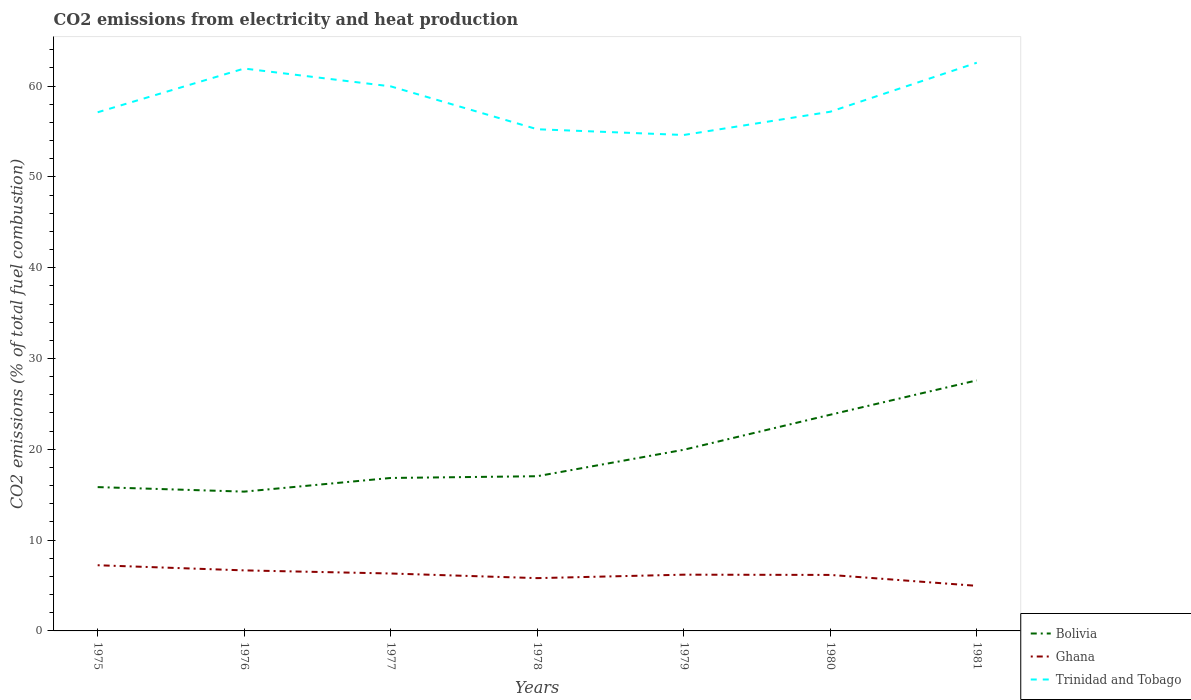How many different coloured lines are there?
Ensure brevity in your answer.  3. Does the line corresponding to Trinidad and Tobago intersect with the line corresponding to Ghana?
Your answer should be compact. No. Is the number of lines equal to the number of legend labels?
Provide a short and direct response. Yes. Across all years, what is the maximum amount of CO2 emitted in Trinidad and Tobago?
Offer a very short reply. 54.62. In which year was the amount of CO2 emitted in Trinidad and Tobago maximum?
Give a very brief answer. 1979. What is the total amount of CO2 emitted in Trinidad and Tobago in the graph?
Your response must be concise. 4.72. What is the difference between the highest and the second highest amount of CO2 emitted in Trinidad and Tobago?
Make the answer very short. 7.96. Is the amount of CO2 emitted in Ghana strictly greater than the amount of CO2 emitted in Trinidad and Tobago over the years?
Ensure brevity in your answer.  Yes. How many years are there in the graph?
Provide a short and direct response. 7. What is the difference between two consecutive major ticks on the Y-axis?
Ensure brevity in your answer.  10. Are the values on the major ticks of Y-axis written in scientific E-notation?
Offer a very short reply. No. Does the graph contain any zero values?
Provide a short and direct response. No. What is the title of the graph?
Offer a terse response. CO2 emissions from electricity and heat production. Does "Mongolia" appear as one of the legend labels in the graph?
Provide a succinct answer. No. What is the label or title of the Y-axis?
Provide a succinct answer. CO2 emissions (% of total fuel combustion). What is the CO2 emissions (% of total fuel combustion) of Bolivia in 1975?
Offer a very short reply. 15.84. What is the CO2 emissions (% of total fuel combustion) in Ghana in 1975?
Offer a very short reply. 7.23. What is the CO2 emissions (% of total fuel combustion) in Trinidad and Tobago in 1975?
Your answer should be compact. 57.12. What is the CO2 emissions (% of total fuel combustion) in Bolivia in 1976?
Your answer should be compact. 15.34. What is the CO2 emissions (% of total fuel combustion) of Ghana in 1976?
Offer a terse response. 6.67. What is the CO2 emissions (% of total fuel combustion) in Trinidad and Tobago in 1976?
Your answer should be compact. 61.93. What is the CO2 emissions (% of total fuel combustion) in Bolivia in 1977?
Your response must be concise. 16.84. What is the CO2 emissions (% of total fuel combustion) in Ghana in 1977?
Give a very brief answer. 6.32. What is the CO2 emissions (% of total fuel combustion) in Trinidad and Tobago in 1977?
Provide a succinct answer. 59.97. What is the CO2 emissions (% of total fuel combustion) of Bolivia in 1978?
Provide a short and direct response. 17.04. What is the CO2 emissions (% of total fuel combustion) of Ghana in 1978?
Offer a terse response. 5.81. What is the CO2 emissions (% of total fuel combustion) of Trinidad and Tobago in 1978?
Provide a short and direct response. 55.25. What is the CO2 emissions (% of total fuel combustion) of Bolivia in 1979?
Offer a very short reply. 19.95. What is the CO2 emissions (% of total fuel combustion) in Ghana in 1979?
Your answer should be very brief. 6.19. What is the CO2 emissions (% of total fuel combustion) in Trinidad and Tobago in 1979?
Offer a very short reply. 54.62. What is the CO2 emissions (% of total fuel combustion) of Bolivia in 1980?
Your answer should be compact. 23.81. What is the CO2 emissions (% of total fuel combustion) of Ghana in 1980?
Give a very brief answer. 6.17. What is the CO2 emissions (% of total fuel combustion) in Trinidad and Tobago in 1980?
Your response must be concise. 57.18. What is the CO2 emissions (% of total fuel combustion) in Bolivia in 1981?
Keep it short and to the point. 27.59. What is the CO2 emissions (% of total fuel combustion) in Ghana in 1981?
Offer a terse response. 4.96. What is the CO2 emissions (% of total fuel combustion) of Trinidad and Tobago in 1981?
Your answer should be compact. 62.57. Across all years, what is the maximum CO2 emissions (% of total fuel combustion) of Bolivia?
Give a very brief answer. 27.59. Across all years, what is the maximum CO2 emissions (% of total fuel combustion) in Ghana?
Make the answer very short. 7.23. Across all years, what is the maximum CO2 emissions (% of total fuel combustion) in Trinidad and Tobago?
Offer a very short reply. 62.57. Across all years, what is the minimum CO2 emissions (% of total fuel combustion) in Bolivia?
Your answer should be compact. 15.34. Across all years, what is the minimum CO2 emissions (% of total fuel combustion) of Ghana?
Provide a short and direct response. 4.96. Across all years, what is the minimum CO2 emissions (% of total fuel combustion) of Trinidad and Tobago?
Offer a terse response. 54.62. What is the total CO2 emissions (% of total fuel combustion) in Bolivia in the graph?
Offer a very short reply. 136.42. What is the total CO2 emissions (% of total fuel combustion) of Ghana in the graph?
Keep it short and to the point. 43.37. What is the total CO2 emissions (% of total fuel combustion) of Trinidad and Tobago in the graph?
Give a very brief answer. 408.64. What is the difference between the CO2 emissions (% of total fuel combustion) in Bolivia in 1975 and that in 1976?
Offer a terse response. 0.5. What is the difference between the CO2 emissions (% of total fuel combustion) in Ghana in 1975 and that in 1976?
Offer a very short reply. 0.57. What is the difference between the CO2 emissions (% of total fuel combustion) of Trinidad and Tobago in 1975 and that in 1976?
Ensure brevity in your answer.  -4.82. What is the difference between the CO2 emissions (% of total fuel combustion) in Bolivia in 1975 and that in 1977?
Provide a short and direct response. -1.01. What is the difference between the CO2 emissions (% of total fuel combustion) in Ghana in 1975 and that in 1977?
Provide a short and direct response. 0.91. What is the difference between the CO2 emissions (% of total fuel combustion) of Trinidad and Tobago in 1975 and that in 1977?
Offer a terse response. -2.85. What is the difference between the CO2 emissions (% of total fuel combustion) in Bolivia in 1975 and that in 1978?
Offer a terse response. -1.2. What is the difference between the CO2 emissions (% of total fuel combustion) of Ghana in 1975 and that in 1978?
Your answer should be very brief. 1.42. What is the difference between the CO2 emissions (% of total fuel combustion) of Trinidad and Tobago in 1975 and that in 1978?
Offer a very short reply. 1.87. What is the difference between the CO2 emissions (% of total fuel combustion) in Bolivia in 1975 and that in 1979?
Offer a very short reply. -4.11. What is the difference between the CO2 emissions (% of total fuel combustion) of Ghana in 1975 and that in 1979?
Your answer should be compact. 1.04. What is the difference between the CO2 emissions (% of total fuel combustion) in Trinidad and Tobago in 1975 and that in 1979?
Provide a short and direct response. 2.5. What is the difference between the CO2 emissions (% of total fuel combustion) in Bolivia in 1975 and that in 1980?
Keep it short and to the point. -7.97. What is the difference between the CO2 emissions (% of total fuel combustion) in Ghana in 1975 and that in 1980?
Your answer should be very brief. 1.07. What is the difference between the CO2 emissions (% of total fuel combustion) in Trinidad and Tobago in 1975 and that in 1980?
Give a very brief answer. -0.06. What is the difference between the CO2 emissions (% of total fuel combustion) of Bolivia in 1975 and that in 1981?
Provide a short and direct response. -11.76. What is the difference between the CO2 emissions (% of total fuel combustion) of Ghana in 1975 and that in 1981?
Ensure brevity in your answer.  2.27. What is the difference between the CO2 emissions (% of total fuel combustion) in Trinidad and Tobago in 1975 and that in 1981?
Provide a succinct answer. -5.46. What is the difference between the CO2 emissions (% of total fuel combustion) in Bolivia in 1976 and that in 1977?
Give a very brief answer. -1.5. What is the difference between the CO2 emissions (% of total fuel combustion) of Ghana in 1976 and that in 1977?
Offer a very short reply. 0.34. What is the difference between the CO2 emissions (% of total fuel combustion) in Trinidad and Tobago in 1976 and that in 1977?
Your response must be concise. 1.96. What is the difference between the CO2 emissions (% of total fuel combustion) of Bolivia in 1976 and that in 1978?
Provide a short and direct response. -1.7. What is the difference between the CO2 emissions (% of total fuel combustion) of Ghana in 1976 and that in 1978?
Provide a succinct answer. 0.85. What is the difference between the CO2 emissions (% of total fuel combustion) of Trinidad and Tobago in 1976 and that in 1978?
Keep it short and to the point. 6.69. What is the difference between the CO2 emissions (% of total fuel combustion) of Bolivia in 1976 and that in 1979?
Provide a succinct answer. -4.61. What is the difference between the CO2 emissions (% of total fuel combustion) in Ghana in 1976 and that in 1979?
Offer a terse response. 0.47. What is the difference between the CO2 emissions (% of total fuel combustion) in Trinidad and Tobago in 1976 and that in 1979?
Make the answer very short. 7.32. What is the difference between the CO2 emissions (% of total fuel combustion) in Bolivia in 1976 and that in 1980?
Offer a very short reply. -8.47. What is the difference between the CO2 emissions (% of total fuel combustion) of Ghana in 1976 and that in 1980?
Keep it short and to the point. 0.5. What is the difference between the CO2 emissions (% of total fuel combustion) in Trinidad and Tobago in 1976 and that in 1980?
Provide a short and direct response. 4.76. What is the difference between the CO2 emissions (% of total fuel combustion) in Bolivia in 1976 and that in 1981?
Provide a short and direct response. -12.25. What is the difference between the CO2 emissions (% of total fuel combustion) in Ghana in 1976 and that in 1981?
Ensure brevity in your answer.  1.7. What is the difference between the CO2 emissions (% of total fuel combustion) of Trinidad and Tobago in 1976 and that in 1981?
Ensure brevity in your answer.  -0.64. What is the difference between the CO2 emissions (% of total fuel combustion) in Bolivia in 1977 and that in 1978?
Your response must be concise. -0.19. What is the difference between the CO2 emissions (% of total fuel combustion) of Ghana in 1977 and that in 1978?
Your answer should be very brief. 0.51. What is the difference between the CO2 emissions (% of total fuel combustion) in Trinidad and Tobago in 1977 and that in 1978?
Keep it short and to the point. 4.72. What is the difference between the CO2 emissions (% of total fuel combustion) in Bolivia in 1977 and that in 1979?
Make the answer very short. -3.11. What is the difference between the CO2 emissions (% of total fuel combustion) of Ghana in 1977 and that in 1979?
Your response must be concise. 0.13. What is the difference between the CO2 emissions (% of total fuel combustion) of Trinidad and Tobago in 1977 and that in 1979?
Give a very brief answer. 5.36. What is the difference between the CO2 emissions (% of total fuel combustion) in Bolivia in 1977 and that in 1980?
Offer a very short reply. -6.96. What is the difference between the CO2 emissions (% of total fuel combustion) of Ghana in 1977 and that in 1980?
Ensure brevity in your answer.  0.16. What is the difference between the CO2 emissions (% of total fuel combustion) of Trinidad and Tobago in 1977 and that in 1980?
Ensure brevity in your answer.  2.79. What is the difference between the CO2 emissions (% of total fuel combustion) of Bolivia in 1977 and that in 1981?
Your response must be concise. -10.75. What is the difference between the CO2 emissions (% of total fuel combustion) of Ghana in 1977 and that in 1981?
Offer a terse response. 1.36. What is the difference between the CO2 emissions (% of total fuel combustion) of Trinidad and Tobago in 1977 and that in 1981?
Your answer should be compact. -2.6. What is the difference between the CO2 emissions (% of total fuel combustion) of Bolivia in 1978 and that in 1979?
Offer a very short reply. -2.91. What is the difference between the CO2 emissions (% of total fuel combustion) in Ghana in 1978 and that in 1979?
Your answer should be very brief. -0.38. What is the difference between the CO2 emissions (% of total fuel combustion) in Trinidad and Tobago in 1978 and that in 1979?
Provide a succinct answer. 0.63. What is the difference between the CO2 emissions (% of total fuel combustion) of Bolivia in 1978 and that in 1980?
Your answer should be very brief. -6.77. What is the difference between the CO2 emissions (% of total fuel combustion) of Ghana in 1978 and that in 1980?
Provide a succinct answer. -0.35. What is the difference between the CO2 emissions (% of total fuel combustion) in Trinidad and Tobago in 1978 and that in 1980?
Offer a very short reply. -1.93. What is the difference between the CO2 emissions (% of total fuel combustion) of Bolivia in 1978 and that in 1981?
Ensure brevity in your answer.  -10.56. What is the difference between the CO2 emissions (% of total fuel combustion) of Ghana in 1978 and that in 1981?
Provide a succinct answer. 0.85. What is the difference between the CO2 emissions (% of total fuel combustion) of Trinidad and Tobago in 1978 and that in 1981?
Give a very brief answer. -7.33. What is the difference between the CO2 emissions (% of total fuel combustion) of Bolivia in 1979 and that in 1980?
Make the answer very short. -3.86. What is the difference between the CO2 emissions (% of total fuel combustion) in Ghana in 1979 and that in 1980?
Ensure brevity in your answer.  0.03. What is the difference between the CO2 emissions (% of total fuel combustion) of Trinidad and Tobago in 1979 and that in 1980?
Your response must be concise. -2.56. What is the difference between the CO2 emissions (% of total fuel combustion) of Bolivia in 1979 and that in 1981?
Provide a succinct answer. -7.64. What is the difference between the CO2 emissions (% of total fuel combustion) in Ghana in 1979 and that in 1981?
Make the answer very short. 1.23. What is the difference between the CO2 emissions (% of total fuel combustion) of Trinidad and Tobago in 1979 and that in 1981?
Your answer should be very brief. -7.96. What is the difference between the CO2 emissions (% of total fuel combustion) of Bolivia in 1980 and that in 1981?
Provide a succinct answer. -3.78. What is the difference between the CO2 emissions (% of total fuel combustion) of Ghana in 1980 and that in 1981?
Make the answer very short. 1.2. What is the difference between the CO2 emissions (% of total fuel combustion) of Trinidad and Tobago in 1980 and that in 1981?
Make the answer very short. -5.4. What is the difference between the CO2 emissions (% of total fuel combustion) of Bolivia in 1975 and the CO2 emissions (% of total fuel combustion) of Ghana in 1976?
Ensure brevity in your answer.  9.17. What is the difference between the CO2 emissions (% of total fuel combustion) of Bolivia in 1975 and the CO2 emissions (% of total fuel combustion) of Trinidad and Tobago in 1976?
Your response must be concise. -46.1. What is the difference between the CO2 emissions (% of total fuel combustion) in Ghana in 1975 and the CO2 emissions (% of total fuel combustion) in Trinidad and Tobago in 1976?
Your answer should be compact. -54.7. What is the difference between the CO2 emissions (% of total fuel combustion) in Bolivia in 1975 and the CO2 emissions (% of total fuel combustion) in Ghana in 1977?
Provide a short and direct response. 9.51. What is the difference between the CO2 emissions (% of total fuel combustion) of Bolivia in 1975 and the CO2 emissions (% of total fuel combustion) of Trinidad and Tobago in 1977?
Provide a succinct answer. -44.13. What is the difference between the CO2 emissions (% of total fuel combustion) of Ghana in 1975 and the CO2 emissions (% of total fuel combustion) of Trinidad and Tobago in 1977?
Offer a very short reply. -52.74. What is the difference between the CO2 emissions (% of total fuel combustion) of Bolivia in 1975 and the CO2 emissions (% of total fuel combustion) of Ghana in 1978?
Your answer should be very brief. 10.02. What is the difference between the CO2 emissions (% of total fuel combustion) in Bolivia in 1975 and the CO2 emissions (% of total fuel combustion) in Trinidad and Tobago in 1978?
Your answer should be very brief. -39.41. What is the difference between the CO2 emissions (% of total fuel combustion) of Ghana in 1975 and the CO2 emissions (% of total fuel combustion) of Trinidad and Tobago in 1978?
Provide a succinct answer. -48.02. What is the difference between the CO2 emissions (% of total fuel combustion) in Bolivia in 1975 and the CO2 emissions (% of total fuel combustion) in Ghana in 1979?
Provide a succinct answer. 9.64. What is the difference between the CO2 emissions (% of total fuel combustion) of Bolivia in 1975 and the CO2 emissions (% of total fuel combustion) of Trinidad and Tobago in 1979?
Give a very brief answer. -38.78. What is the difference between the CO2 emissions (% of total fuel combustion) of Ghana in 1975 and the CO2 emissions (% of total fuel combustion) of Trinidad and Tobago in 1979?
Your response must be concise. -47.38. What is the difference between the CO2 emissions (% of total fuel combustion) in Bolivia in 1975 and the CO2 emissions (% of total fuel combustion) in Ghana in 1980?
Offer a very short reply. 9.67. What is the difference between the CO2 emissions (% of total fuel combustion) in Bolivia in 1975 and the CO2 emissions (% of total fuel combustion) in Trinidad and Tobago in 1980?
Keep it short and to the point. -41.34. What is the difference between the CO2 emissions (% of total fuel combustion) of Ghana in 1975 and the CO2 emissions (% of total fuel combustion) of Trinidad and Tobago in 1980?
Give a very brief answer. -49.94. What is the difference between the CO2 emissions (% of total fuel combustion) of Bolivia in 1975 and the CO2 emissions (% of total fuel combustion) of Ghana in 1981?
Keep it short and to the point. 10.87. What is the difference between the CO2 emissions (% of total fuel combustion) in Bolivia in 1975 and the CO2 emissions (% of total fuel combustion) in Trinidad and Tobago in 1981?
Give a very brief answer. -46.74. What is the difference between the CO2 emissions (% of total fuel combustion) in Ghana in 1975 and the CO2 emissions (% of total fuel combustion) in Trinidad and Tobago in 1981?
Offer a terse response. -55.34. What is the difference between the CO2 emissions (% of total fuel combustion) of Bolivia in 1976 and the CO2 emissions (% of total fuel combustion) of Ghana in 1977?
Keep it short and to the point. 9.02. What is the difference between the CO2 emissions (% of total fuel combustion) in Bolivia in 1976 and the CO2 emissions (% of total fuel combustion) in Trinidad and Tobago in 1977?
Your response must be concise. -44.63. What is the difference between the CO2 emissions (% of total fuel combustion) in Ghana in 1976 and the CO2 emissions (% of total fuel combustion) in Trinidad and Tobago in 1977?
Ensure brevity in your answer.  -53.31. What is the difference between the CO2 emissions (% of total fuel combustion) in Bolivia in 1976 and the CO2 emissions (% of total fuel combustion) in Ghana in 1978?
Your response must be concise. 9.53. What is the difference between the CO2 emissions (% of total fuel combustion) in Bolivia in 1976 and the CO2 emissions (% of total fuel combustion) in Trinidad and Tobago in 1978?
Give a very brief answer. -39.91. What is the difference between the CO2 emissions (% of total fuel combustion) of Ghana in 1976 and the CO2 emissions (% of total fuel combustion) of Trinidad and Tobago in 1978?
Offer a very short reply. -48.58. What is the difference between the CO2 emissions (% of total fuel combustion) of Bolivia in 1976 and the CO2 emissions (% of total fuel combustion) of Ghana in 1979?
Your answer should be very brief. 9.15. What is the difference between the CO2 emissions (% of total fuel combustion) of Bolivia in 1976 and the CO2 emissions (% of total fuel combustion) of Trinidad and Tobago in 1979?
Ensure brevity in your answer.  -39.28. What is the difference between the CO2 emissions (% of total fuel combustion) of Ghana in 1976 and the CO2 emissions (% of total fuel combustion) of Trinidad and Tobago in 1979?
Your answer should be very brief. -47.95. What is the difference between the CO2 emissions (% of total fuel combustion) in Bolivia in 1976 and the CO2 emissions (% of total fuel combustion) in Ghana in 1980?
Offer a very short reply. 9.17. What is the difference between the CO2 emissions (% of total fuel combustion) in Bolivia in 1976 and the CO2 emissions (% of total fuel combustion) in Trinidad and Tobago in 1980?
Ensure brevity in your answer.  -41.84. What is the difference between the CO2 emissions (% of total fuel combustion) in Ghana in 1976 and the CO2 emissions (% of total fuel combustion) in Trinidad and Tobago in 1980?
Provide a succinct answer. -50.51. What is the difference between the CO2 emissions (% of total fuel combustion) of Bolivia in 1976 and the CO2 emissions (% of total fuel combustion) of Ghana in 1981?
Your response must be concise. 10.38. What is the difference between the CO2 emissions (% of total fuel combustion) of Bolivia in 1976 and the CO2 emissions (% of total fuel combustion) of Trinidad and Tobago in 1981?
Offer a very short reply. -47.23. What is the difference between the CO2 emissions (% of total fuel combustion) in Ghana in 1976 and the CO2 emissions (% of total fuel combustion) in Trinidad and Tobago in 1981?
Offer a terse response. -55.91. What is the difference between the CO2 emissions (% of total fuel combustion) of Bolivia in 1977 and the CO2 emissions (% of total fuel combustion) of Ghana in 1978?
Your response must be concise. 11.03. What is the difference between the CO2 emissions (% of total fuel combustion) in Bolivia in 1977 and the CO2 emissions (% of total fuel combustion) in Trinidad and Tobago in 1978?
Ensure brevity in your answer.  -38.4. What is the difference between the CO2 emissions (% of total fuel combustion) in Ghana in 1977 and the CO2 emissions (% of total fuel combustion) in Trinidad and Tobago in 1978?
Your answer should be compact. -48.93. What is the difference between the CO2 emissions (% of total fuel combustion) in Bolivia in 1977 and the CO2 emissions (% of total fuel combustion) in Ghana in 1979?
Your response must be concise. 10.65. What is the difference between the CO2 emissions (% of total fuel combustion) of Bolivia in 1977 and the CO2 emissions (% of total fuel combustion) of Trinidad and Tobago in 1979?
Your answer should be compact. -37.77. What is the difference between the CO2 emissions (% of total fuel combustion) of Ghana in 1977 and the CO2 emissions (% of total fuel combustion) of Trinidad and Tobago in 1979?
Make the answer very short. -48.29. What is the difference between the CO2 emissions (% of total fuel combustion) of Bolivia in 1977 and the CO2 emissions (% of total fuel combustion) of Ghana in 1980?
Keep it short and to the point. 10.68. What is the difference between the CO2 emissions (% of total fuel combustion) in Bolivia in 1977 and the CO2 emissions (% of total fuel combustion) in Trinidad and Tobago in 1980?
Keep it short and to the point. -40.33. What is the difference between the CO2 emissions (% of total fuel combustion) of Ghana in 1977 and the CO2 emissions (% of total fuel combustion) of Trinidad and Tobago in 1980?
Your answer should be very brief. -50.85. What is the difference between the CO2 emissions (% of total fuel combustion) in Bolivia in 1977 and the CO2 emissions (% of total fuel combustion) in Ghana in 1981?
Provide a succinct answer. 11.88. What is the difference between the CO2 emissions (% of total fuel combustion) of Bolivia in 1977 and the CO2 emissions (% of total fuel combustion) of Trinidad and Tobago in 1981?
Keep it short and to the point. -45.73. What is the difference between the CO2 emissions (% of total fuel combustion) of Ghana in 1977 and the CO2 emissions (% of total fuel combustion) of Trinidad and Tobago in 1981?
Make the answer very short. -56.25. What is the difference between the CO2 emissions (% of total fuel combustion) in Bolivia in 1978 and the CO2 emissions (% of total fuel combustion) in Ghana in 1979?
Give a very brief answer. 10.84. What is the difference between the CO2 emissions (% of total fuel combustion) of Bolivia in 1978 and the CO2 emissions (% of total fuel combustion) of Trinidad and Tobago in 1979?
Provide a succinct answer. -37.58. What is the difference between the CO2 emissions (% of total fuel combustion) of Ghana in 1978 and the CO2 emissions (% of total fuel combustion) of Trinidad and Tobago in 1979?
Ensure brevity in your answer.  -48.8. What is the difference between the CO2 emissions (% of total fuel combustion) in Bolivia in 1978 and the CO2 emissions (% of total fuel combustion) in Ghana in 1980?
Make the answer very short. 10.87. What is the difference between the CO2 emissions (% of total fuel combustion) of Bolivia in 1978 and the CO2 emissions (% of total fuel combustion) of Trinidad and Tobago in 1980?
Your response must be concise. -40.14. What is the difference between the CO2 emissions (% of total fuel combustion) in Ghana in 1978 and the CO2 emissions (% of total fuel combustion) in Trinidad and Tobago in 1980?
Offer a very short reply. -51.36. What is the difference between the CO2 emissions (% of total fuel combustion) in Bolivia in 1978 and the CO2 emissions (% of total fuel combustion) in Ghana in 1981?
Your answer should be compact. 12.07. What is the difference between the CO2 emissions (% of total fuel combustion) of Bolivia in 1978 and the CO2 emissions (% of total fuel combustion) of Trinidad and Tobago in 1981?
Provide a succinct answer. -45.54. What is the difference between the CO2 emissions (% of total fuel combustion) of Ghana in 1978 and the CO2 emissions (% of total fuel combustion) of Trinidad and Tobago in 1981?
Provide a short and direct response. -56.76. What is the difference between the CO2 emissions (% of total fuel combustion) in Bolivia in 1979 and the CO2 emissions (% of total fuel combustion) in Ghana in 1980?
Offer a very short reply. 13.78. What is the difference between the CO2 emissions (% of total fuel combustion) in Bolivia in 1979 and the CO2 emissions (% of total fuel combustion) in Trinidad and Tobago in 1980?
Give a very brief answer. -37.23. What is the difference between the CO2 emissions (% of total fuel combustion) in Ghana in 1979 and the CO2 emissions (% of total fuel combustion) in Trinidad and Tobago in 1980?
Offer a very short reply. -50.98. What is the difference between the CO2 emissions (% of total fuel combustion) in Bolivia in 1979 and the CO2 emissions (% of total fuel combustion) in Ghana in 1981?
Your answer should be very brief. 14.99. What is the difference between the CO2 emissions (% of total fuel combustion) of Bolivia in 1979 and the CO2 emissions (% of total fuel combustion) of Trinidad and Tobago in 1981?
Ensure brevity in your answer.  -42.62. What is the difference between the CO2 emissions (% of total fuel combustion) in Ghana in 1979 and the CO2 emissions (% of total fuel combustion) in Trinidad and Tobago in 1981?
Give a very brief answer. -56.38. What is the difference between the CO2 emissions (% of total fuel combustion) of Bolivia in 1980 and the CO2 emissions (% of total fuel combustion) of Ghana in 1981?
Give a very brief answer. 18.84. What is the difference between the CO2 emissions (% of total fuel combustion) in Bolivia in 1980 and the CO2 emissions (% of total fuel combustion) in Trinidad and Tobago in 1981?
Offer a very short reply. -38.77. What is the difference between the CO2 emissions (% of total fuel combustion) in Ghana in 1980 and the CO2 emissions (% of total fuel combustion) in Trinidad and Tobago in 1981?
Keep it short and to the point. -56.41. What is the average CO2 emissions (% of total fuel combustion) of Bolivia per year?
Offer a very short reply. 19.49. What is the average CO2 emissions (% of total fuel combustion) of Ghana per year?
Keep it short and to the point. 6.2. What is the average CO2 emissions (% of total fuel combustion) of Trinidad and Tobago per year?
Give a very brief answer. 58.38. In the year 1975, what is the difference between the CO2 emissions (% of total fuel combustion) in Bolivia and CO2 emissions (% of total fuel combustion) in Ghana?
Give a very brief answer. 8.6. In the year 1975, what is the difference between the CO2 emissions (% of total fuel combustion) of Bolivia and CO2 emissions (% of total fuel combustion) of Trinidad and Tobago?
Offer a very short reply. -41.28. In the year 1975, what is the difference between the CO2 emissions (% of total fuel combustion) in Ghana and CO2 emissions (% of total fuel combustion) in Trinidad and Tobago?
Provide a succinct answer. -49.88. In the year 1976, what is the difference between the CO2 emissions (% of total fuel combustion) of Bolivia and CO2 emissions (% of total fuel combustion) of Ghana?
Your answer should be compact. 8.67. In the year 1976, what is the difference between the CO2 emissions (% of total fuel combustion) of Bolivia and CO2 emissions (% of total fuel combustion) of Trinidad and Tobago?
Ensure brevity in your answer.  -46.59. In the year 1976, what is the difference between the CO2 emissions (% of total fuel combustion) of Ghana and CO2 emissions (% of total fuel combustion) of Trinidad and Tobago?
Your response must be concise. -55.27. In the year 1977, what is the difference between the CO2 emissions (% of total fuel combustion) of Bolivia and CO2 emissions (% of total fuel combustion) of Ghana?
Provide a short and direct response. 10.52. In the year 1977, what is the difference between the CO2 emissions (% of total fuel combustion) of Bolivia and CO2 emissions (% of total fuel combustion) of Trinidad and Tobago?
Ensure brevity in your answer.  -43.13. In the year 1977, what is the difference between the CO2 emissions (% of total fuel combustion) of Ghana and CO2 emissions (% of total fuel combustion) of Trinidad and Tobago?
Your answer should be compact. -53.65. In the year 1978, what is the difference between the CO2 emissions (% of total fuel combustion) of Bolivia and CO2 emissions (% of total fuel combustion) of Ghana?
Ensure brevity in your answer.  11.22. In the year 1978, what is the difference between the CO2 emissions (% of total fuel combustion) of Bolivia and CO2 emissions (% of total fuel combustion) of Trinidad and Tobago?
Provide a short and direct response. -38.21. In the year 1978, what is the difference between the CO2 emissions (% of total fuel combustion) of Ghana and CO2 emissions (% of total fuel combustion) of Trinidad and Tobago?
Your answer should be compact. -49.44. In the year 1979, what is the difference between the CO2 emissions (% of total fuel combustion) in Bolivia and CO2 emissions (% of total fuel combustion) in Ghana?
Offer a very short reply. 13.76. In the year 1979, what is the difference between the CO2 emissions (% of total fuel combustion) in Bolivia and CO2 emissions (% of total fuel combustion) in Trinidad and Tobago?
Provide a short and direct response. -34.67. In the year 1979, what is the difference between the CO2 emissions (% of total fuel combustion) of Ghana and CO2 emissions (% of total fuel combustion) of Trinidad and Tobago?
Keep it short and to the point. -48.42. In the year 1980, what is the difference between the CO2 emissions (% of total fuel combustion) of Bolivia and CO2 emissions (% of total fuel combustion) of Ghana?
Offer a terse response. 17.64. In the year 1980, what is the difference between the CO2 emissions (% of total fuel combustion) in Bolivia and CO2 emissions (% of total fuel combustion) in Trinidad and Tobago?
Offer a very short reply. -33.37. In the year 1980, what is the difference between the CO2 emissions (% of total fuel combustion) of Ghana and CO2 emissions (% of total fuel combustion) of Trinidad and Tobago?
Provide a succinct answer. -51.01. In the year 1981, what is the difference between the CO2 emissions (% of total fuel combustion) in Bolivia and CO2 emissions (% of total fuel combustion) in Ghana?
Provide a succinct answer. 22.63. In the year 1981, what is the difference between the CO2 emissions (% of total fuel combustion) in Bolivia and CO2 emissions (% of total fuel combustion) in Trinidad and Tobago?
Your response must be concise. -34.98. In the year 1981, what is the difference between the CO2 emissions (% of total fuel combustion) in Ghana and CO2 emissions (% of total fuel combustion) in Trinidad and Tobago?
Provide a succinct answer. -57.61. What is the ratio of the CO2 emissions (% of total fuel combustion) in Bolivia in 1975 to that in 1976?
Your response must be concise. 1.03. What is the ratio of the CO2 emissions (% of total fuel combustion) in Ghana in 1975 to that in 1976?
Make the answer very short. 1.09. What is the ratio of the CO2 emissions (% of total fuel combustion) of Trinidad and Tobago in 1975 to that in 1976?
Your response must be concise. 0.92. What is the ratio of the CO2 emissions (% of total fuel combustion) of Bolivia in 1975 to that in 1977?
Your answer should be compact. 0.94. What is the ratio of the CO2 emissions (% of total fuel combustion) of Ghana in 1975 to that in 1977?
Offer a terse response. 1.14. What is the ratio of the CO2 emissions (% of total fuel combustion) of Trinidad and Tobago in 1975 to that in 1977?
Your response must be concise. 0.95. What is the ratio of the CO2 emissions (% of total fuel combustion) in Bolivia in 1975 to that in 1978?
Provide a succinct answer. 0.93. What is the ratio of the CO2 emissions (% of total fuel combustion) in Ghana in 1975 to that in 1978?
Keep it short and to the point. 1.24. What is the ratio of the CO2 emissions (% of total fuel combustion) of Trinidad and Tobago in 1975 to that in 1978?
Keep it short and to the point. 1.03. What is the ratio of the CO2 emissions (% of total fuel combustion) in Bolivia in 1975 to that in 1979?
Your response must be concise. 0.79. What is the ratio of the CO2 emissions (% of total fuel combustion) in Ghana in 1975 to that in 1979?
Your response must be concise. 1.17. What is the ratio of the CO2 emissions (% of total fuel combustion) of Trinidad and Tobago in 1975 to that in 1979?
Make the answer very short. 1.05. What is the ratio of the CO2 emissions (% of total fuel combustion) of Bolivia in 1975 to that in 1980?
Offer a terse response. 0.67. What is the ratio of the CO2 emissions (% of total fuel combustion) of Ghana in 1975 to that in 1980?
Your answer should be compact. 1.17. What is the ratio of the CO2 emissions (% of total fuel combustion) of Bolivia in 1975 to that in 1981?
Your response must be concise. 0.57. What is the ratio of the CO2 emissions (% of total fuel combustion) of Ghana in 1975 to that in 1981?
Keep it short and to the point. 1.46. What is the ratio of the CO2 emissions (% of total fuel combustion) of Trinidad and Tobago in 1975 to that in 1981?
Your answer should be compact. 0.91. What is the ratio of the CO2 emissions (% of total fuel combustion) in Bolivia in 1976 to that in 1977?
Your response must be concise. 0.91. What is the ratio of the CO2 emissions (% of total fuel combustion) of Ghana in 1976 to that in 1977?
Provide a short and direct response. 1.05. What is the ratio of the CO2 emissions (% of total fuel combustion) of Trinidad and Tobago in 1976 to that in 1977?
Give a very brief answer. 1.03. What is the ratio of the CO2 emissions (% of total fuel combustion) in Bolivia in 1976 to that in 1978?
Give a very brief answer. 0.9. What is the ratio of the CO2 emissions (% of total fuel combustion) in Ghana in 1976 to that in 1978?
Your answer should be compact. 1.15. What is the ratio of the CO2 emissions (% of total fuel combustion) of Trinidad and Tobago in 1976 to that in 1978?
Give a very brief answer. 1.12. What is the ratio of the CO2 emissions (% of total fuel combustion) of Bolivia in 1976 to that in 1979?
Give a very brief answer. 0.77. What is the ratio of the CO2 emissions (% of total fuel combustion) of Ghana in 1976 to that in 1979?
Make the answer very short. 1.08. What is the ratio of the CO2 emissions (% of total fuel combustion) of Trinidad and Tobago in 1976 to that in 1979?
Keep it short and to the point. 1.13. What is the ratio of the CO2 emissions (% of total fuel combustion) in Bolivia in 1976 to that in 1980?
Provide a succinct answer. 0.64. What is the ratio of the CO2 emissions (% of total fuel combustion) in Ghana in 1976 to that in 1980?
Provide a succinct answer. 1.08. What is the ratio of the CO2 emissions (% of total fuel combustion) of Trinidad and Tobago in 1976 to that in 1980?
Keep it short and to the point. 1.08. What is the ratio of the CO2 emissions (% of total fuel combustion) of Bolivia in 1976 to that in 1981?
Provide a short and direct response. 0.56. What is the ratio of the CO2 emissions (% of total fuel combustion) of Ghana in 1976 to that in 1981?
Your answer should be compact. 1.34. What is the ratio of the CO2 emissions (% of total fuel combustion) of Trinidad and Tobago in 1976 to that in 1981?
Provide a short and direct response. 0.99. What is the ratio of the CO2 emissions (% of total fuel combustion) in Bolivia in 1977 to that in 1978?
Offer a terse response. 0.99. What is the ratio of the CO2 emissions (% of total fuel combustion) of Ghana in 1977 to that in 1978?
Make the answer very short. 1.09. What is the ratio of the CO2 emissions (% of total fuel combustion) of Trinidad and Tobago in 1977 to that in 1978?
Your response must be concise. 1.09. What is the ratio of the CO2 emissions (% of total fuel combustion) in Bolivia in 1977 to that in 1979?
Your answer should be compact. 0.84. What is the ratio of the CO2 emissions (% of total fuel combustion) in Ghana in 1977 to that in 1979?
Provide a succinct answer. 1.02. What is the ratio of the CO2 emissions (% of total fuel combustion) in Trinidad and Tobago in 1977 to that in 1979?
Provide a short and direct response. 1.1. What is the ratio of the CO2 emissions (% of total fuel combustion) in Bolivia in 1977 to that in 1980?
Give a very brief answer. 0.71. What is the ratio of the CO2 emissions (% of total fuel combustion) in Ghana in 1977 to that in 1980?
Give a very brief answer. 1.03. What is the ratio of the CO2 emissions (% of total fuel combustion) in Trinidad and Tobago in 1977 to that in 1980?
Provide a succinct answer. 1.05. What is the ratio of the CO2 emissions (% of total fuel combustion) of Bolivia in 1977 to that in 1981?
Ensure brevity in your answer.  0.61. What is the ratio of the CO2 emissions (% of total fuel combustion) of Ghana in 1977 to that in 1981?
Your answer should be compact. 1.27. What is the ratio of the CO2 emissions (% of total fuel combustion) in Trinidad and Tobago in 1977 to that in 1981?
Provide a short and direct response. 0.96. What is the ratio of the CO2 emissions (% of total fuel combustion) in Bolivia in 1978 to that in 1979?
Keep it short and to the point. 0.85. What is the ratio of the CO2 emissions (% of total fuel combustion) of Ghana in 1978 to that in 1979?
Provide a short and direct response. 0.94. What is the ratio of the CO2 emissions (% of total fuel combustion) of Trinidad and Tobago in 1978 to that in 1979?
Ensure brevity in your answer.  1.01. What is the ratio of the CO2 emissions (% of total fuel combustion) in Bolivia in 1978 to that in 1980?
Give a very brief answer. 0.72. What is the ratio of the CO2 emissions (% of total fuel combustion) of Ghana in 1978 to that in 1980?
Provide a short and direct response. 0.94. What is the ratio of the CO2 emissions (% of total fuel combustion) of Trinidad and Tobago in 1978 to that in 1980?
Provide a short and direct response. 0.97. What is the ratio of the CO2 emissions (% of total fuel combustion) of Bolivia in 1978 to that in 1981?
Keep it short and to the point. 0.62. What is the ratio of the CO2 emissions (% of total fuel combustion) in Ghana in 1978 to that in 1981?
Offer a terse response. 1.17. What is the ratio of the CO2 emissions (% of total fuel combustion) in Trinidad and Tobago in 1978 to that in 1981?
Give a very brief answer. 0.88. What is the ratio of the CO2 emissions (% of total fuel combustion) in Bolivia in 1979 to that in 1980?
Offer a terse response. 0.84. What is the ratio of the CO2 emissions (% of total fuel combustion) in Ghana in 1979 to that in 1980?
Keep it short and to the point. 1. What is the ratio of the CO2 emissions (% of total fuel combustion) of Trinidad and Tobago in 1979 to that in 1980?
Offer a very short reply. 0.96. What is the ratio of the CO2 emissions (% of total fuel combustion) in Bolivia in 1979 to that in 1981?
Offer a terse response. 0.72. What is the ratio of the CO2 emissions (% of total fuel combustion) of Ghana in 1979 to that in 1981?
Give a very brief answer. 1.25. What is the ratio of the CO2 emissions (% of total fuel combustion) of Trinidad and Tobago in 1979 to that in 1981?
Give a very brief answer. 0.87. What is the ratio of the CO2 emissions (% of total fuel combustion) in Bolivia in 1980 to that in 1981?
Provide a succinct answer. 0.86. What is the ratio of the CO2 emissions (% of total fuel combustion) in Ghana in 1980 to that in 1981?
Your response must be concise. 1.24. What is the ratio of the CO2 emissions (% of total fuel combustion) in Trinidad and Tobago in 1980 to that in 1981?
Keep it short and to the point. 0.91. What is the difference between the highest and the second highest CO2 emissions (% of total fuel combustion) in Bolivia?
Your response must be concise. 3.78. What is the difference between the highest and the second highest CO2 emissions (% of total fuel combustion) of Ghana?
Keep it short and to the point. 0.57. What is the difference between the highest and the second highest CO2 emissions (% of total fuel combustion) of Trinidad and Tobago?
Give a very brief answer. 0.64. What is the difference between the highest and the lowest CO2 emissions (% of total fuel combustion) of Bolivia?
Offer a very short reply. 12.25. What is the difference between the highest and the lowest CO2 emissions (% of total fuel combustion) in Ghana?
Give a very brief answer. 2.27. What is the difference between the highest and the lowest CO2 emissions (% of total fuel combustion) of Trinidad and Tobago?
Offer a terse response. 7.96. 